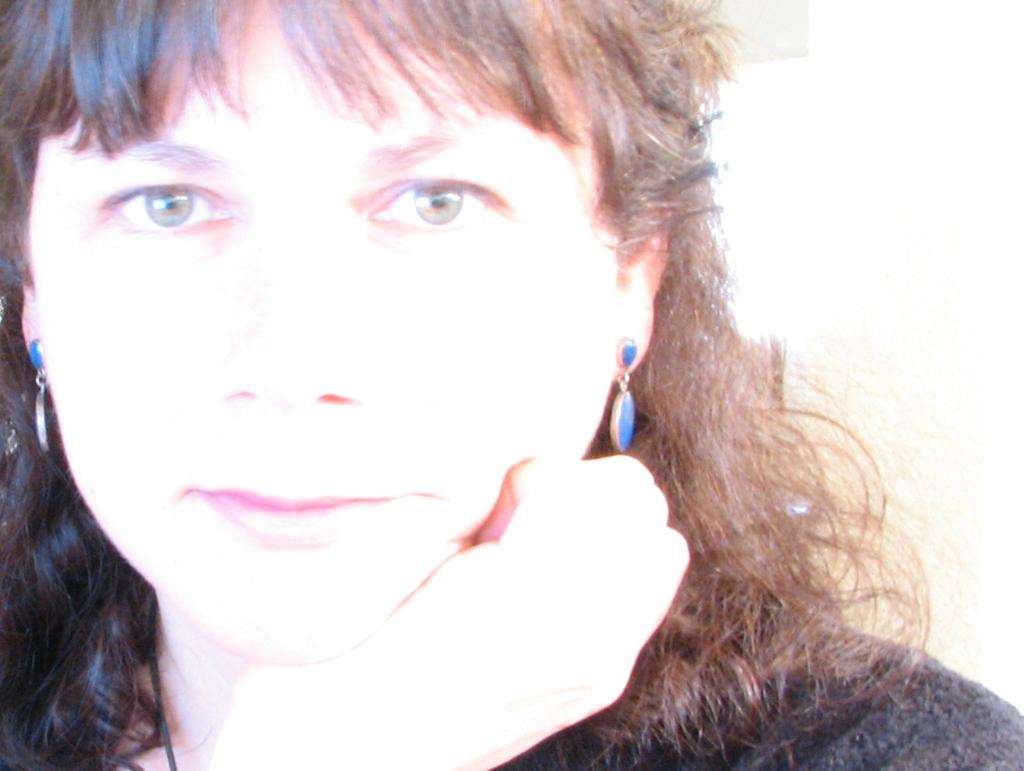What is the main subject of the image? The main subject of the image is a woman's face. What type of hen is sitting on the woman's shoulder in the image? There is no hen present in the image; it only features a woman's face. 